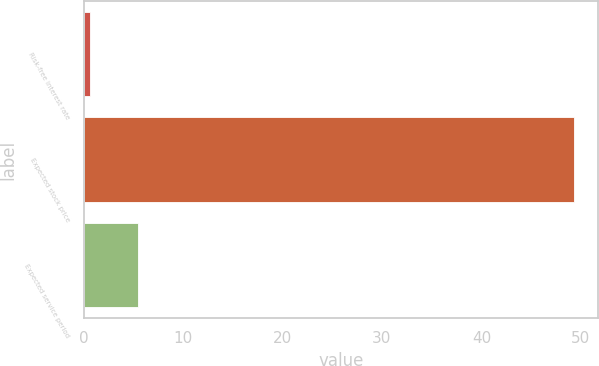Convert chart. <chart><loc_0><loc_0><loc_500><loc_500><bar_chart><fcel>Risk-free interest rate<fcel>Expected stock price<fcel>Expected service period<nl><fcel>0.6<fcel>49.3<fcel>5.47<nl></chart> 